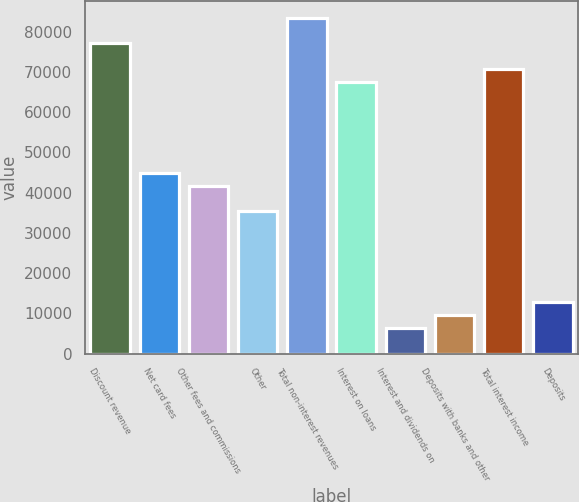Convert chart to OTSL. <chart><loc_0><loc_0><loc_500><loc_500><bar_chart><fcel>Discount revenue<fcel>Net card fees<fcel>Other fees and commissions<fcel>Other<fcel>Total non-interest revenues<fcel>Interest on loans<fcel>Interest and dividends on<fcel>Deposits with banks and other<fcel>Total interest income<fcel>Deposits<nl><fcel>77077.7<fcel>44964.3<fcel>41753<fcel>35330.3<fcel>83500.4<fcel>67443.7<fcel>6428.32<fcel>9639.65<fcel>70655<fcel>12851<nl></chart> 